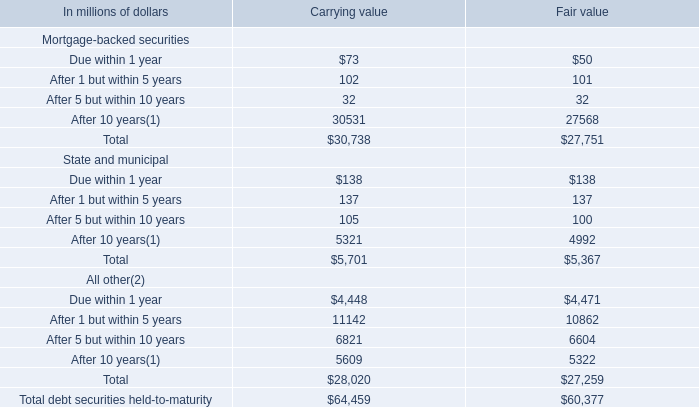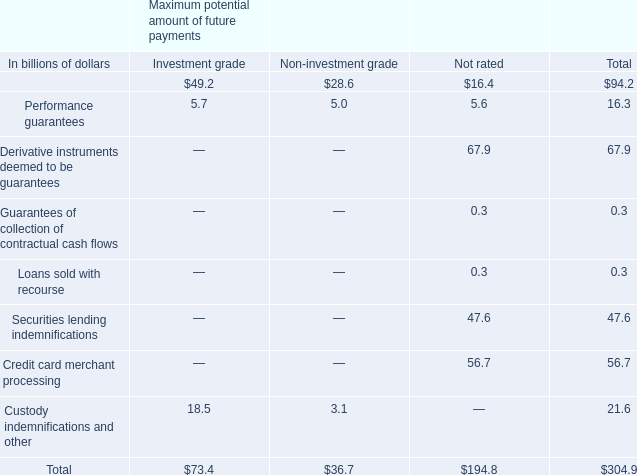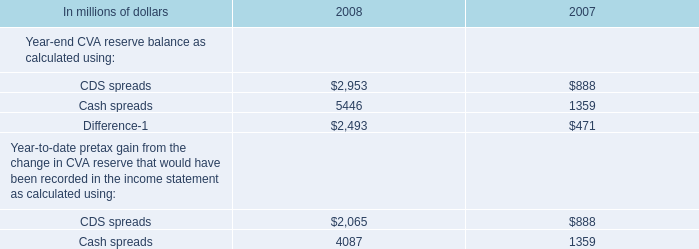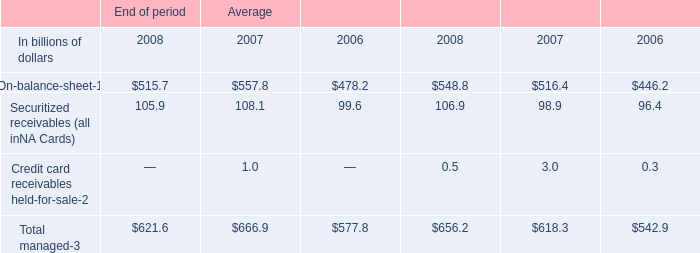What is the sum of After 10 years of Carrying value, Cash spreads of 2008, and Total All other of Carrying value ? 
Computations: ((30531.0 + 5446.0) + 28020.0)
Answer: 63997.0. 